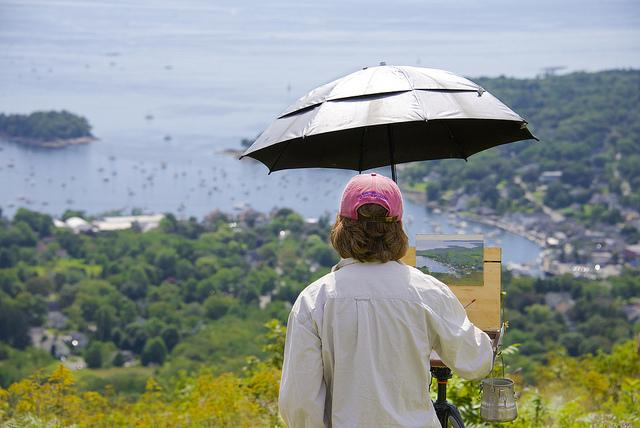What is in the metal tin? water 